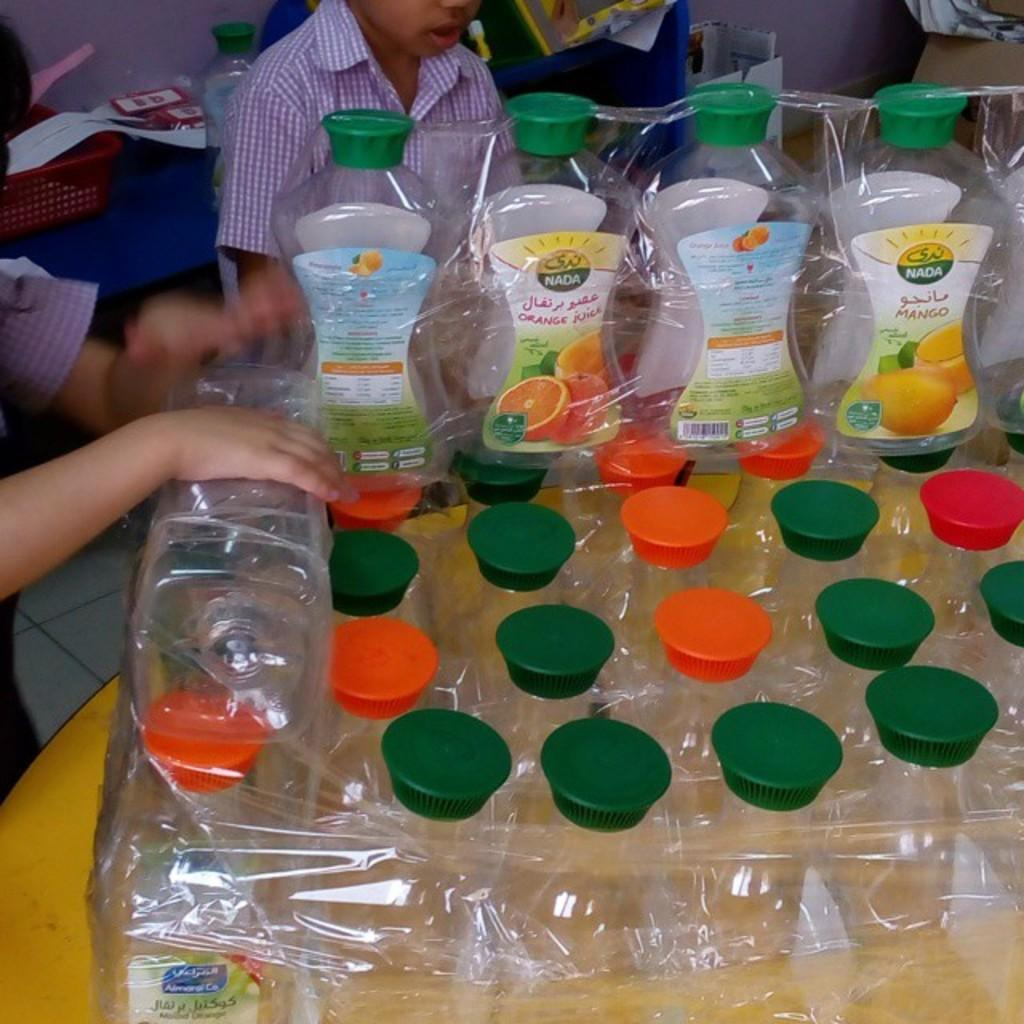What is the main object in the image? There is a table in the image. What is on the table? Packed bottles are present on the table. Where are the children in the image? The children are in the background of the image, on the left side. What type of brush can be seen in the hands of the children? There is no brush present in the image; the children are not holding anything. 